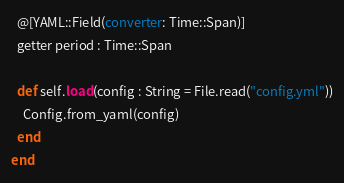Convert code to text. <code><loc_0><loc_0><loc_500><loc_500><_Crystal_>  @[YAML::Field(converter: Time::Span)]
  getter period : Time::Span

  def self.load(config : String = File.read("config.yml"))
    Config.from_yaml(config)
  end
end
</code> 